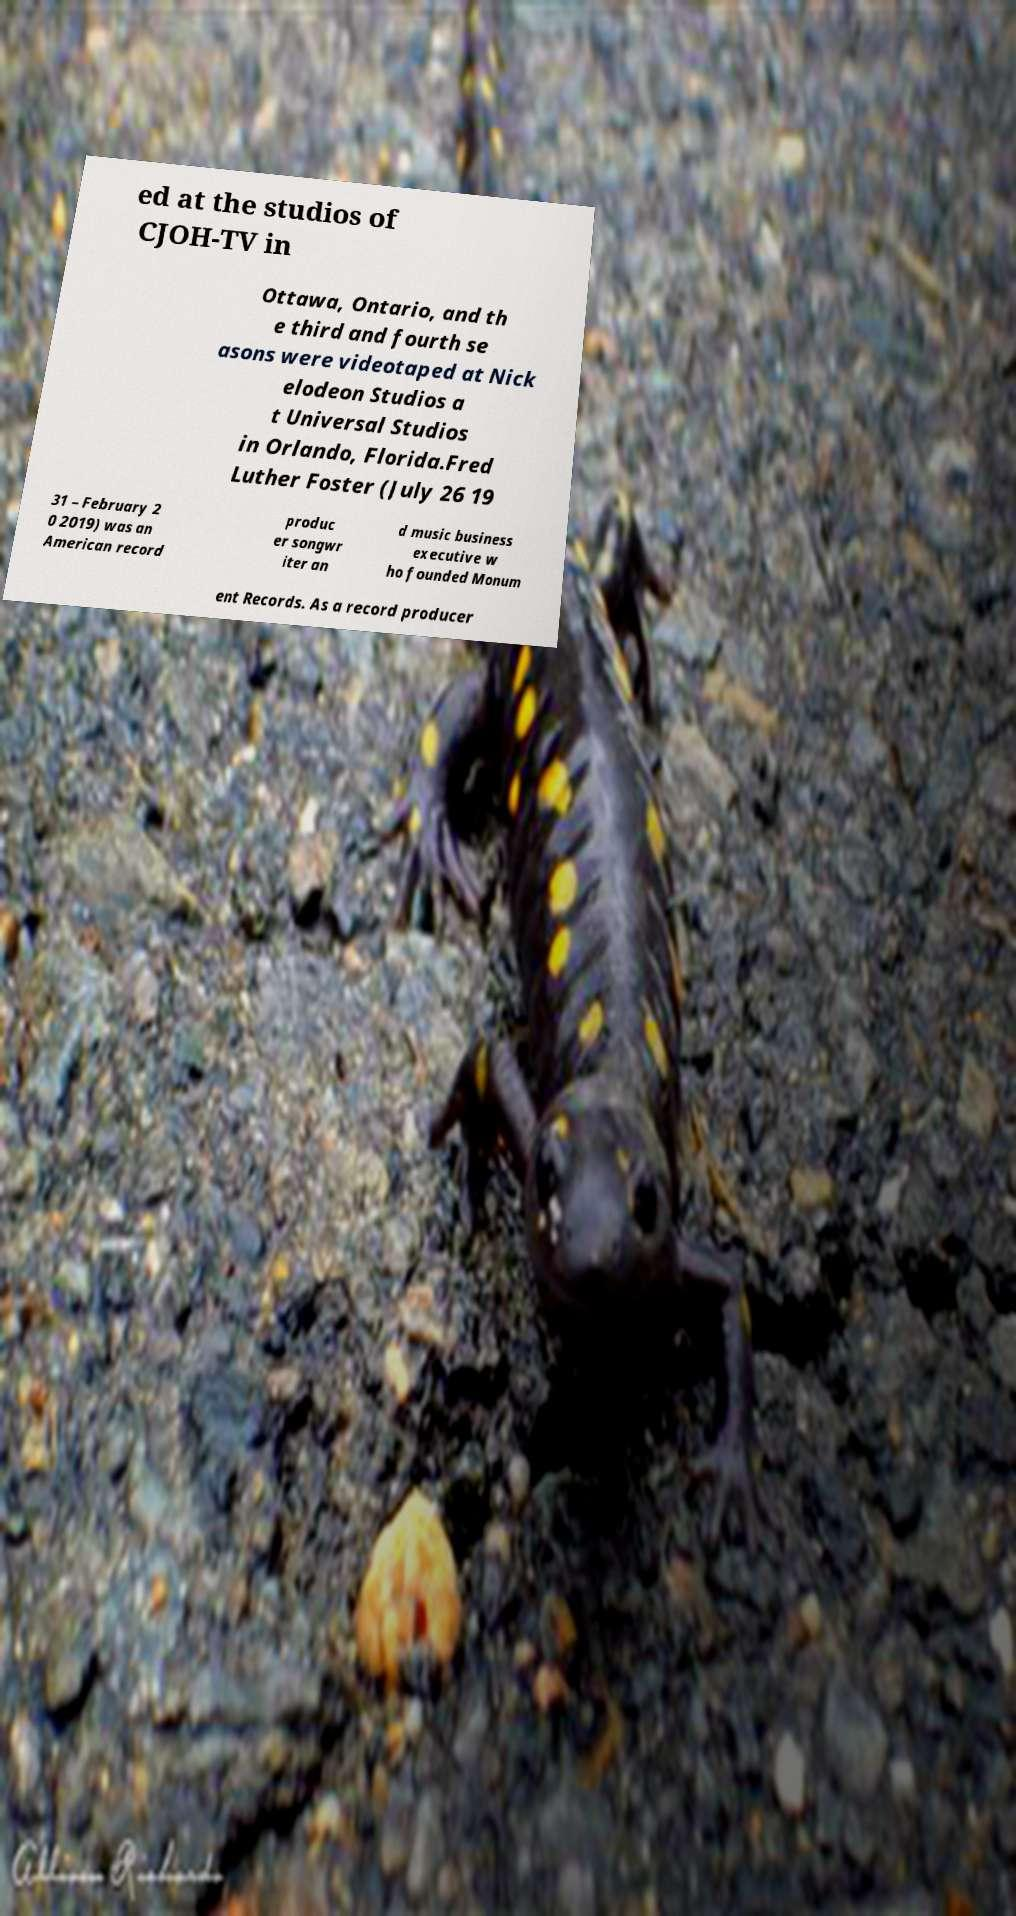Could you assist in decoding the text presented in this image and type it out clearly? ed at the studios of CJOH-TV in Ottawa, Ontario, and th e third and fourth se asons were videotaped at Nick elodeon Studios a t Universal Studios in Orlando, Florida.Fred Luther Foster (July 26 19 31 – February 2 0 2019) was an American record produc er songwr iter an d music business executive w ho founded Monum ent Records. As a record producer 